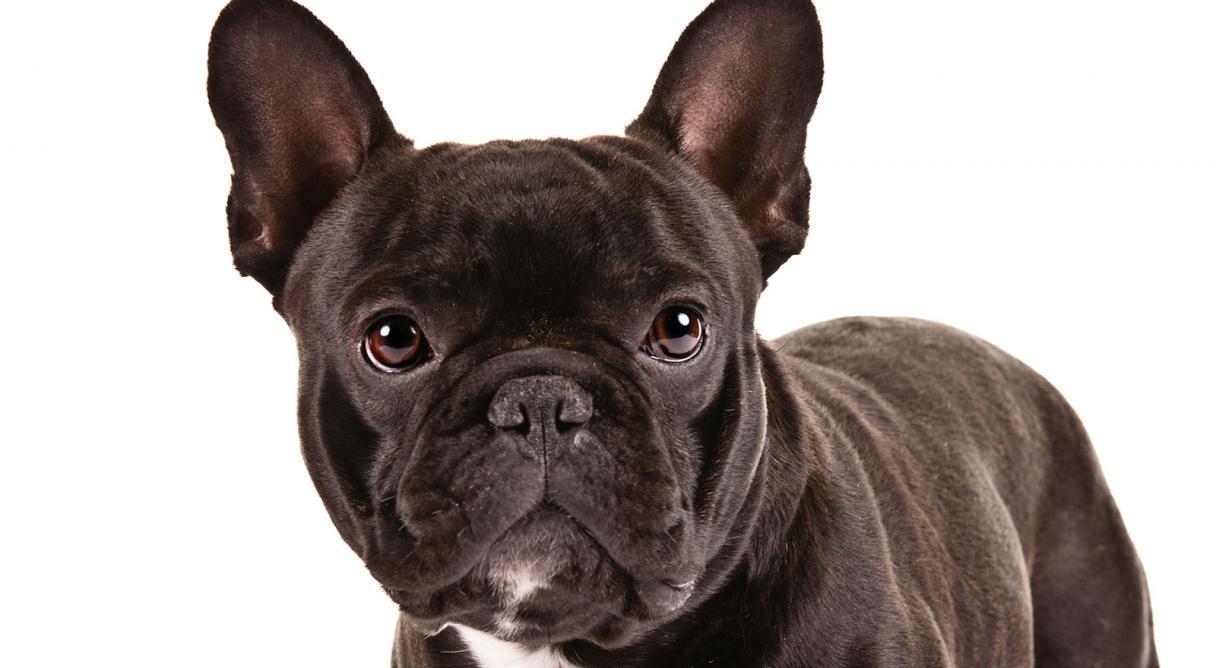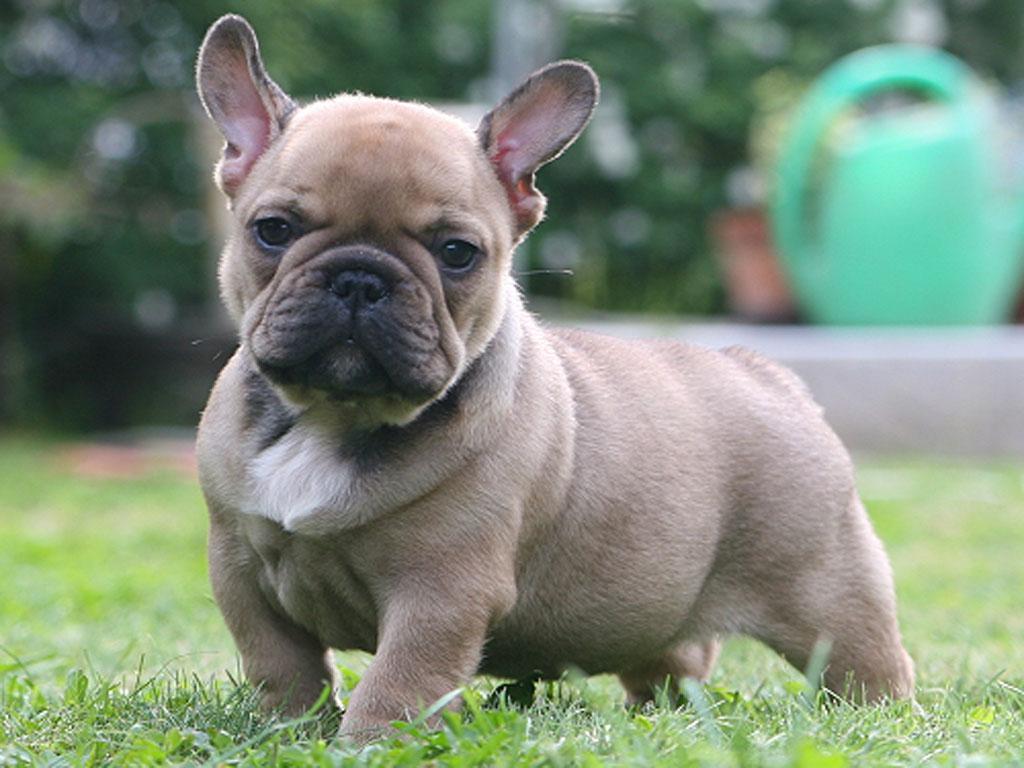The first image is the image on the left, the second image is the image on the right. Analyze the images presented: Is the assertion "There is at least one dog standing on grass-covered ground." valid? Answer yes or no. Yes. The first image is the image on the left, the second image is the image on the right. Given the left and right images, does the statement "There are two french bulldogs, and zero english bulldogs." hold true? Answer yes or no. Yes. 